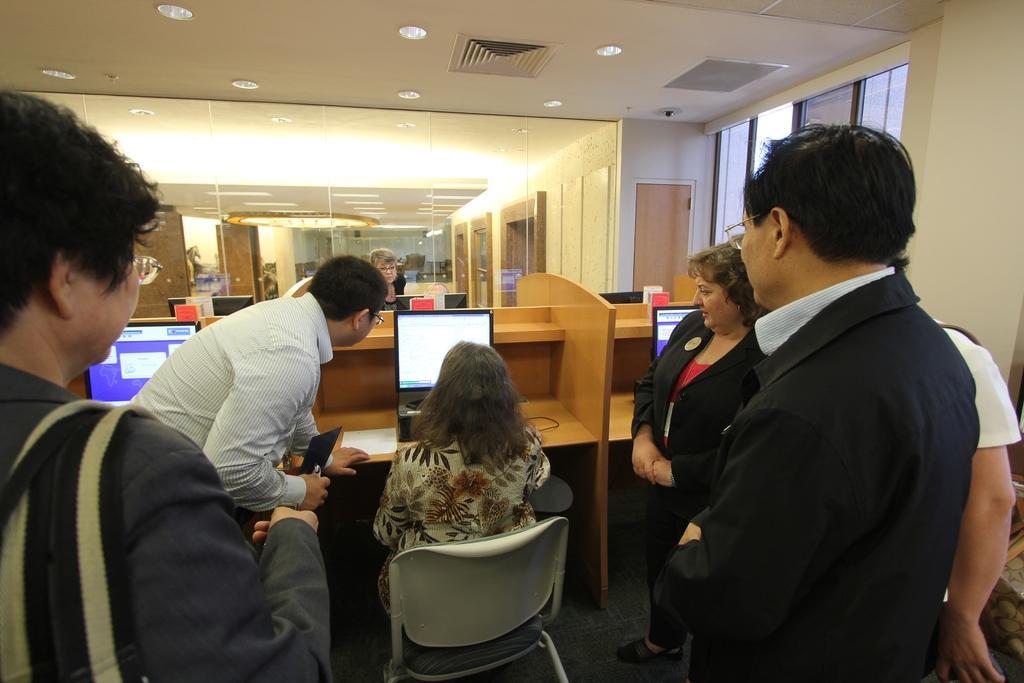Could you give a brief overview of what you see in this image? At the bottom of the image few people are standing and watching. In the middle of the image a woman is sitting. Behind her there is a table, on the table there are some screens. Behind the table there is a glass wall. At the top of the image there is ceiling and lights. 